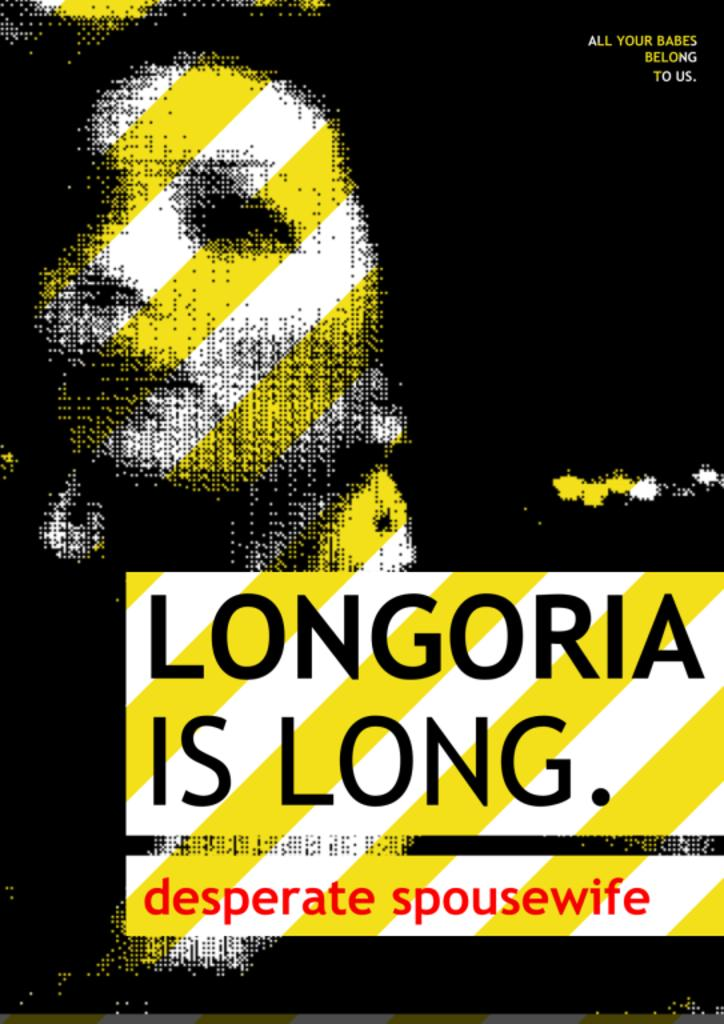What is the main subject on the left side of the image? There is a blurred image of a woman on the left side of the image. What colors is the woman wearing? The woman is wearing a combination of black and yellow colors. What can be found at the bottom of the image? There is text at the bottom of the image. What colors are used for the text? The text is in black and red colors. What month is depicted in the image? There is no month depicted in the image; it features a blurred image of a woman and text at the bottom. Can you see any pests in the image? There are no pests present in the image. 